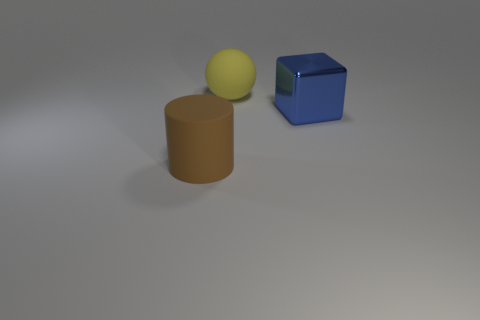What number of things are either yellow spheres that are behind the brown rubber thing or blue objects right of the large brown object?
Give a very brief answer. 2. How many other objects are the same color as the metallic cube?
Provide a short and direct response. 0. Are there more brown objects that are in front of the metallic cube than big yellow spheres in front of the brown rubber cylinder?
Offer a very short reply. Yes. How many balls are either big blue things or big brown objects?
Your answer should be very brief. 0. How many things are either matte objects that are behind the big block or small purple balls?
Give a very brief answer. 1. What shape is the large thing right of the large matte object that is behind the brown cylinder that is to the left of the large yellow ball?
Offer a very short reply. Cube. How many other big rubber things are the same shape as the large brown matte thing?
Offer a very short reply. 0. Do the large yellow object and the brown cylinder have the same material?
Provide a short and direct response. Yes. There is a large rubber object that is behind the cylinder left of the big sphere; how many large blocks are behind it?
Your response must be concise. 0. Are there any large cubes made of the same material as the large brown object?
Provide a short and direct response. No. 